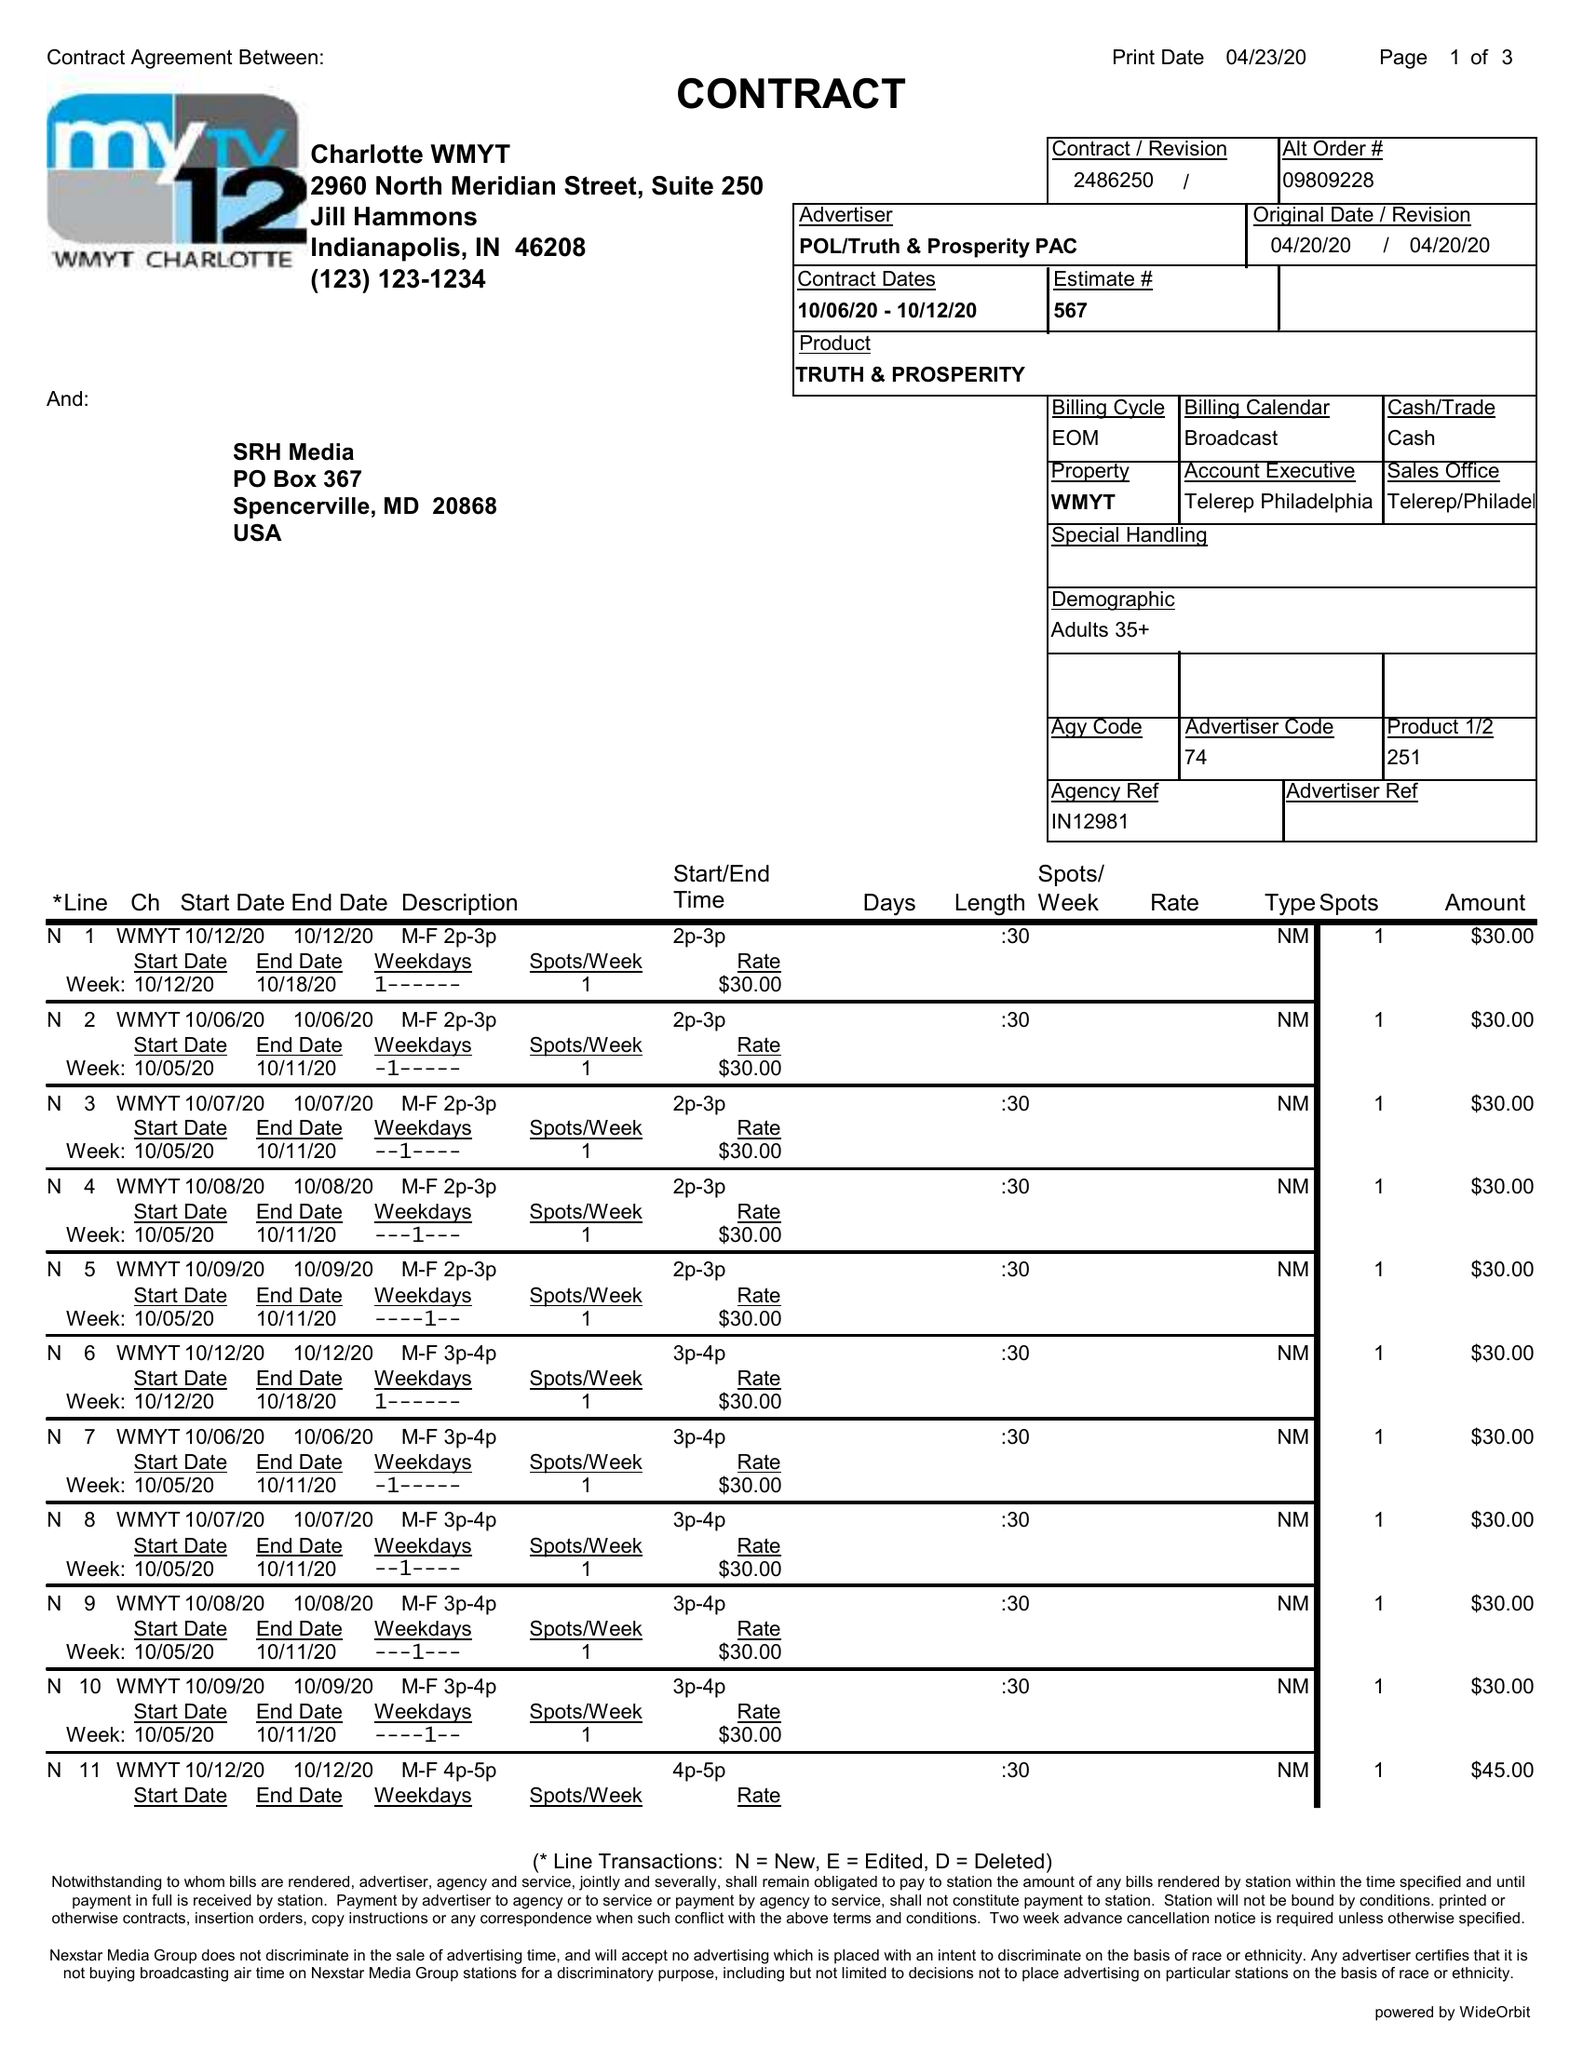What is the value for the gross_amount?
Answer the question using a single word or phrase. 1650.00 